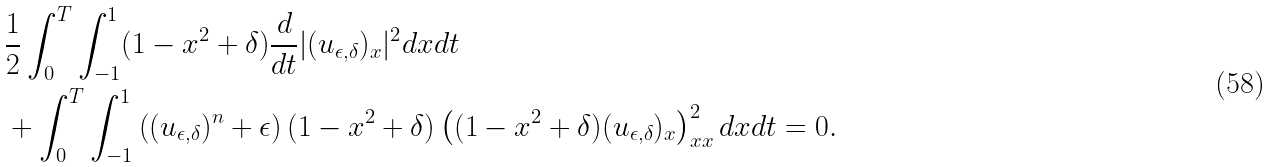<formula> <loc_0><loc_0><loc_500><loc_500>& \frac { 1 } { 2 } \int _ { 0 } ^ { T } \int _ { - 1 } ^ { 1 } ( 1 - x ^ { 2 } + \delta ) \frac { d } { d t } | ( u _ { \epsilon , \delta } ) _ { x } | ^ { 2 } d x d t \\ & + \int _ { 0 } ^ { T } \int _ { - 1 } ^ { 1 } \left ( ( u _ { \epsilon , \delta } ) ^ { n } + \epsilon \right ) ( 1 - x ^ { 2 } + \delta ) \left ( ( 1 - x ^ { 2 } + \delta ) ( u _ { \epsilon , \delta } ) _ { x } \right ) _ { x x } ^ { 2 } d x d t = 0 .</formula> 